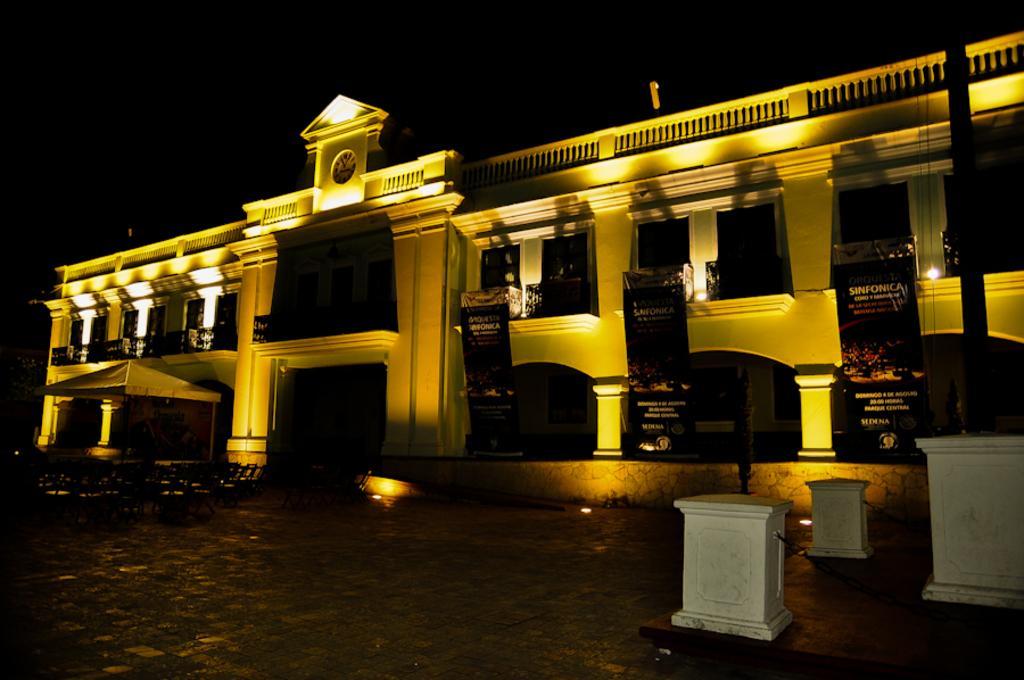How would you summarize this image in a sentence or two? This image is taken outdoors. At the top of the image there is the sky. The sky is dark. At the bottom of the image there is a floor. In the middle of the image there is a building with walls, windows, pillars, a door, railings, a clock and a roof. There are a few banners with text on them and there are a few lights. On the right side of the image there are three stones on the ground. 